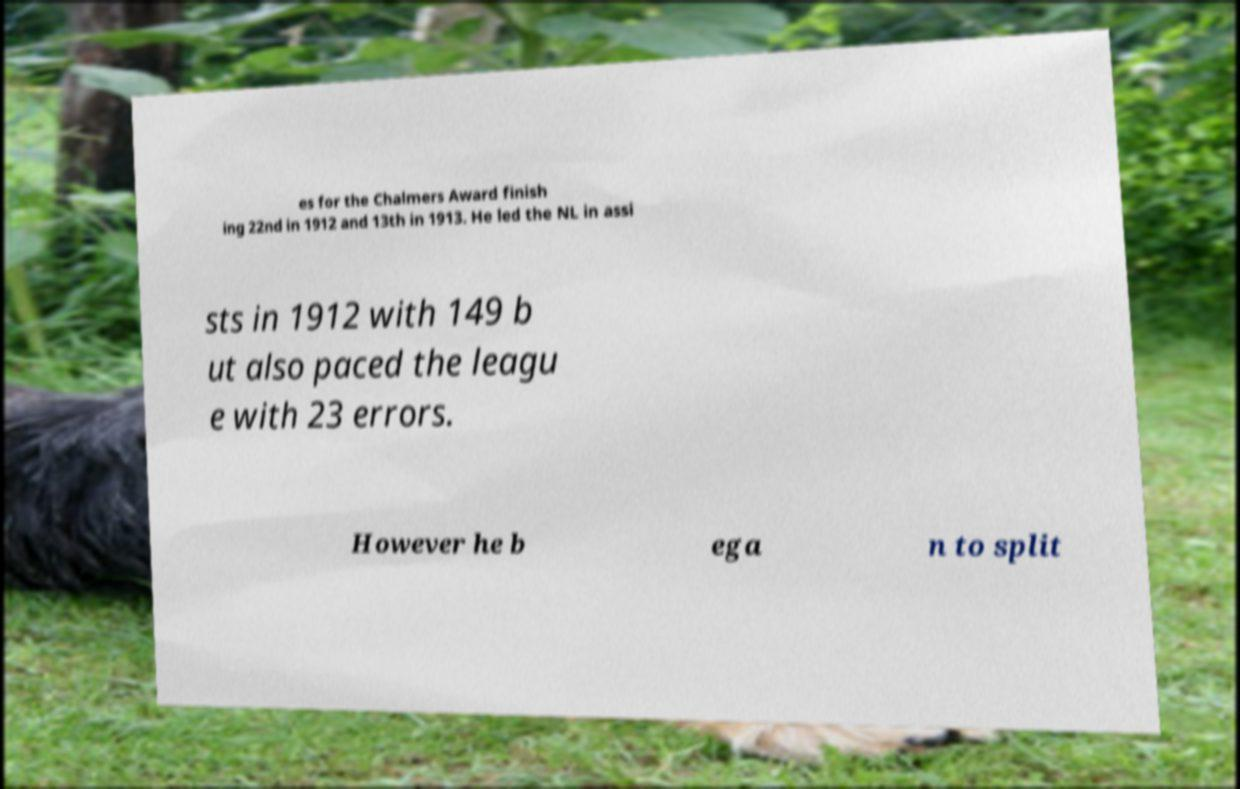Please read and relay the text visible in this image. What does it say? es for the Chalmers Award finish ing 22nd in 1912 and 13th in 1913. He led the NL in assi sts in 1912 with 149 b ut also paced the leagu e with 23 errors. However he b ega n to split 